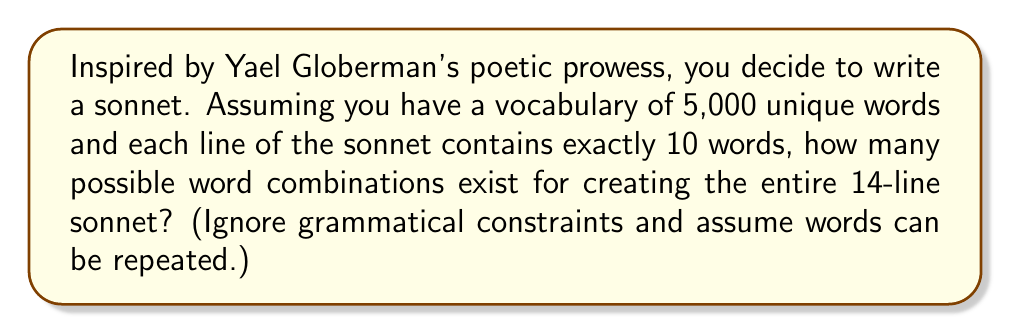Can you answer this question? Let's approach this step-by-step:

1) A sonnet has 14 lines, and we're assuming each line has exactly 10 words.

2) For each word position, we have 5,000 choices (our vocabulary size), and we can repeat words.

3) This scenario is a case of combinations with repetition allowed. The formula for this is:

   $$n^r$$

   where $n$ is the number of items to choose from (vocabulary size) and $r$ is the number of items being chosen (words in the sonnet).

4) In this case:
   $n = 5,000$ (vocabulary size)
   $r = 14 \times 10 = 140$ (total words in the sonnet)

5) Therefore, the number of possible word combinations is:

   $$(5,000)^{140}$$

6) This is an extremely large number. We can express it in scientific notation:

   $$5,000^{140} = (5 \times 10^3)^{140} = 5^{140} \times 10^{420} \approx 1.64 \times 10^{488}$$

This immense number illustrates the vast creative possibilities in poetry, even with a relatively limited vocabulary.
Answer: Approximately $1.64 \times 10^{488}$ possible word combinations 